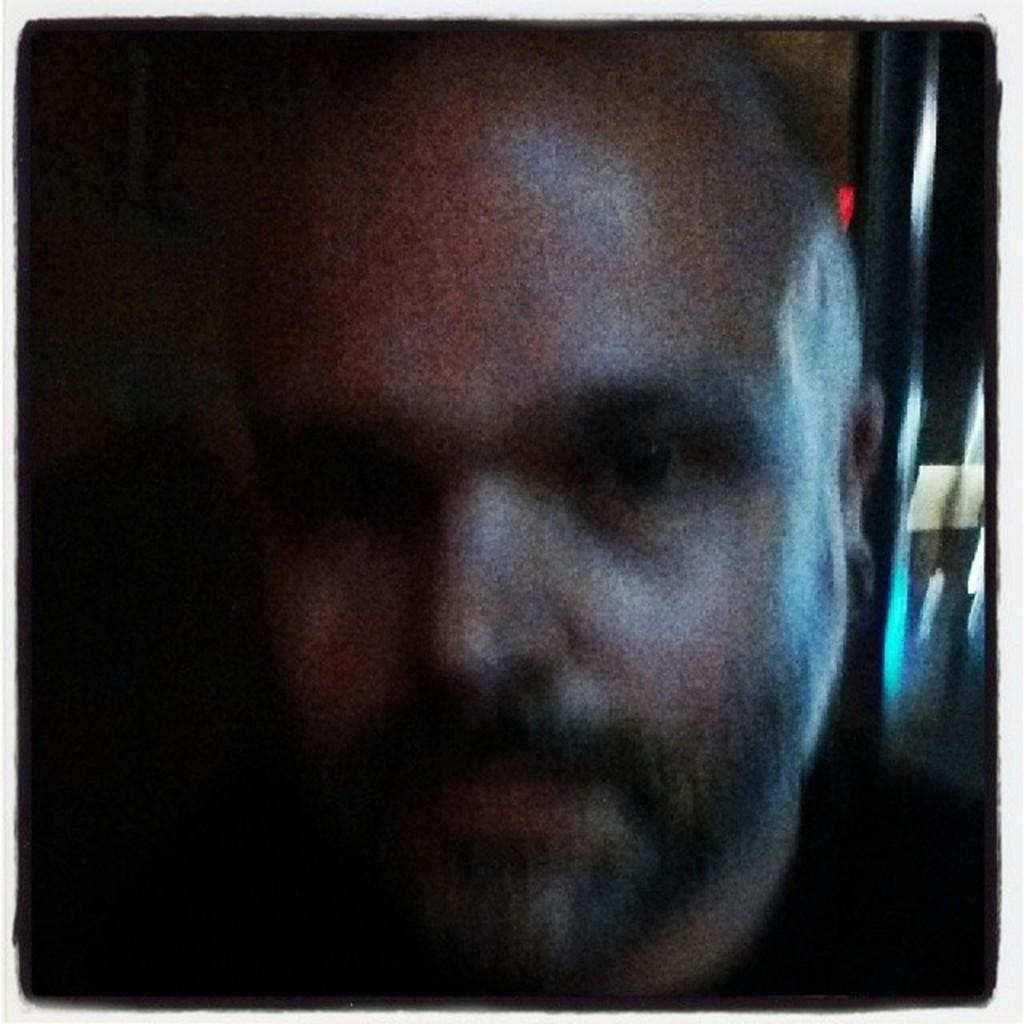What is the main subject in the foreground of the image? There is a man in the foreground of the image. Can you describe the background of the image? The background of the image is blurred. What type of mint is the man chewing in the image? There is no mint present in the image, and the man's actions are not described. How is the man using glue in the image? There is no glue present in the image, and the man's actions are not described. 